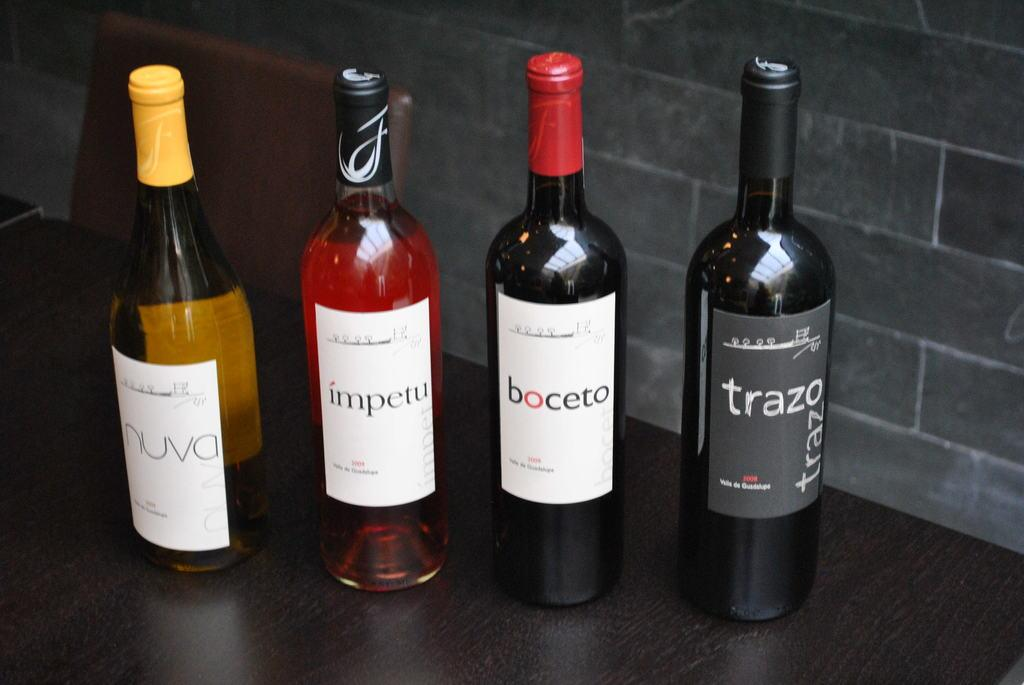How many glass bottles are visible in the image? There are four glass bottles in the image. Can you describe the ghost that is interacting with the glass bottles in the image? There is no ghost present in the image; it only features four glass bottles. 